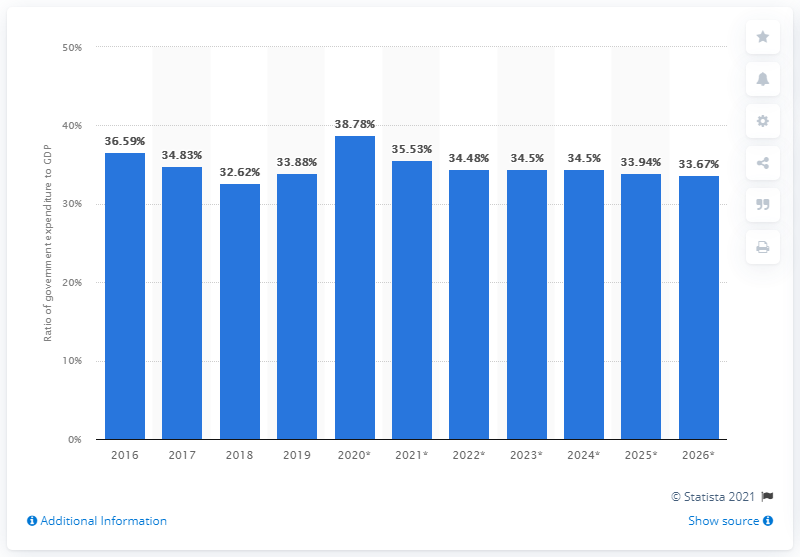Highlight a few significant elements in this photo. In 2019, government expenditure in Russia accounted for 33.67% of the country's gross domestic product. 